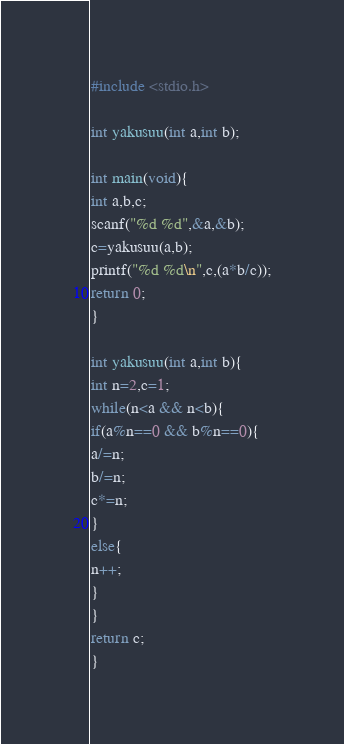<code> <loc_0><loc_0><loc_500><loc_500><_C_>#include <stdio.h>
 
int yakusuu(int a,int b);
 
int main(void){
int a,b,c;
scanf("%d %d",&a,&b);
c=yakusuu(a,b);
printf("%d %d\n",c,(a*b/c));
return 0;
}
 
int yakusuu(int a,int b){
int n=2,c=1;
while(n<a && n<b){
if(a%n==0 && b%n==0){
a/=n;
b/=n;
c*=n;
}
else{
n++;
}
}
return c;
}</code> 